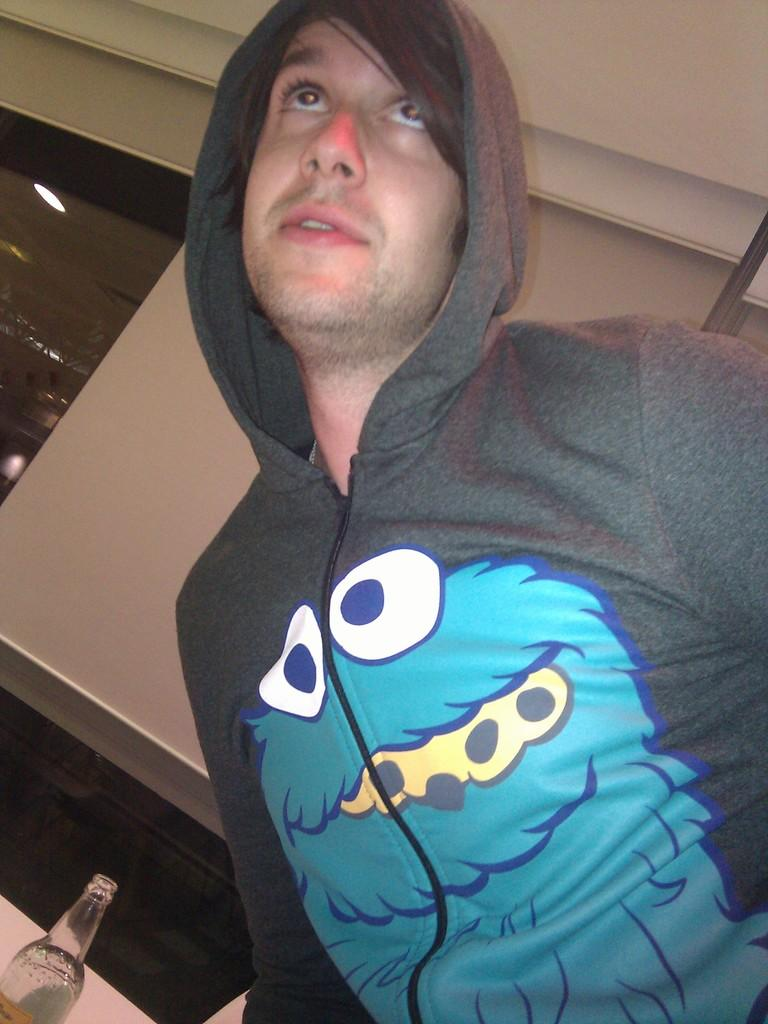Who is present in the image? There is a man in the image. What is the man wearing? The man is wearing a hoodie. What object can be seen in the image besides the man? There is a bottle in the image. What type of lighting is present in the background of the image? There is a light on the ceiling in the background of the image. What type of cherries can be seen on the pancake in the image? There is no pancake or cherries present in the image. What sense is being used to perceive the image? The image is being perceived visually, as it is a photograph or illustration. 